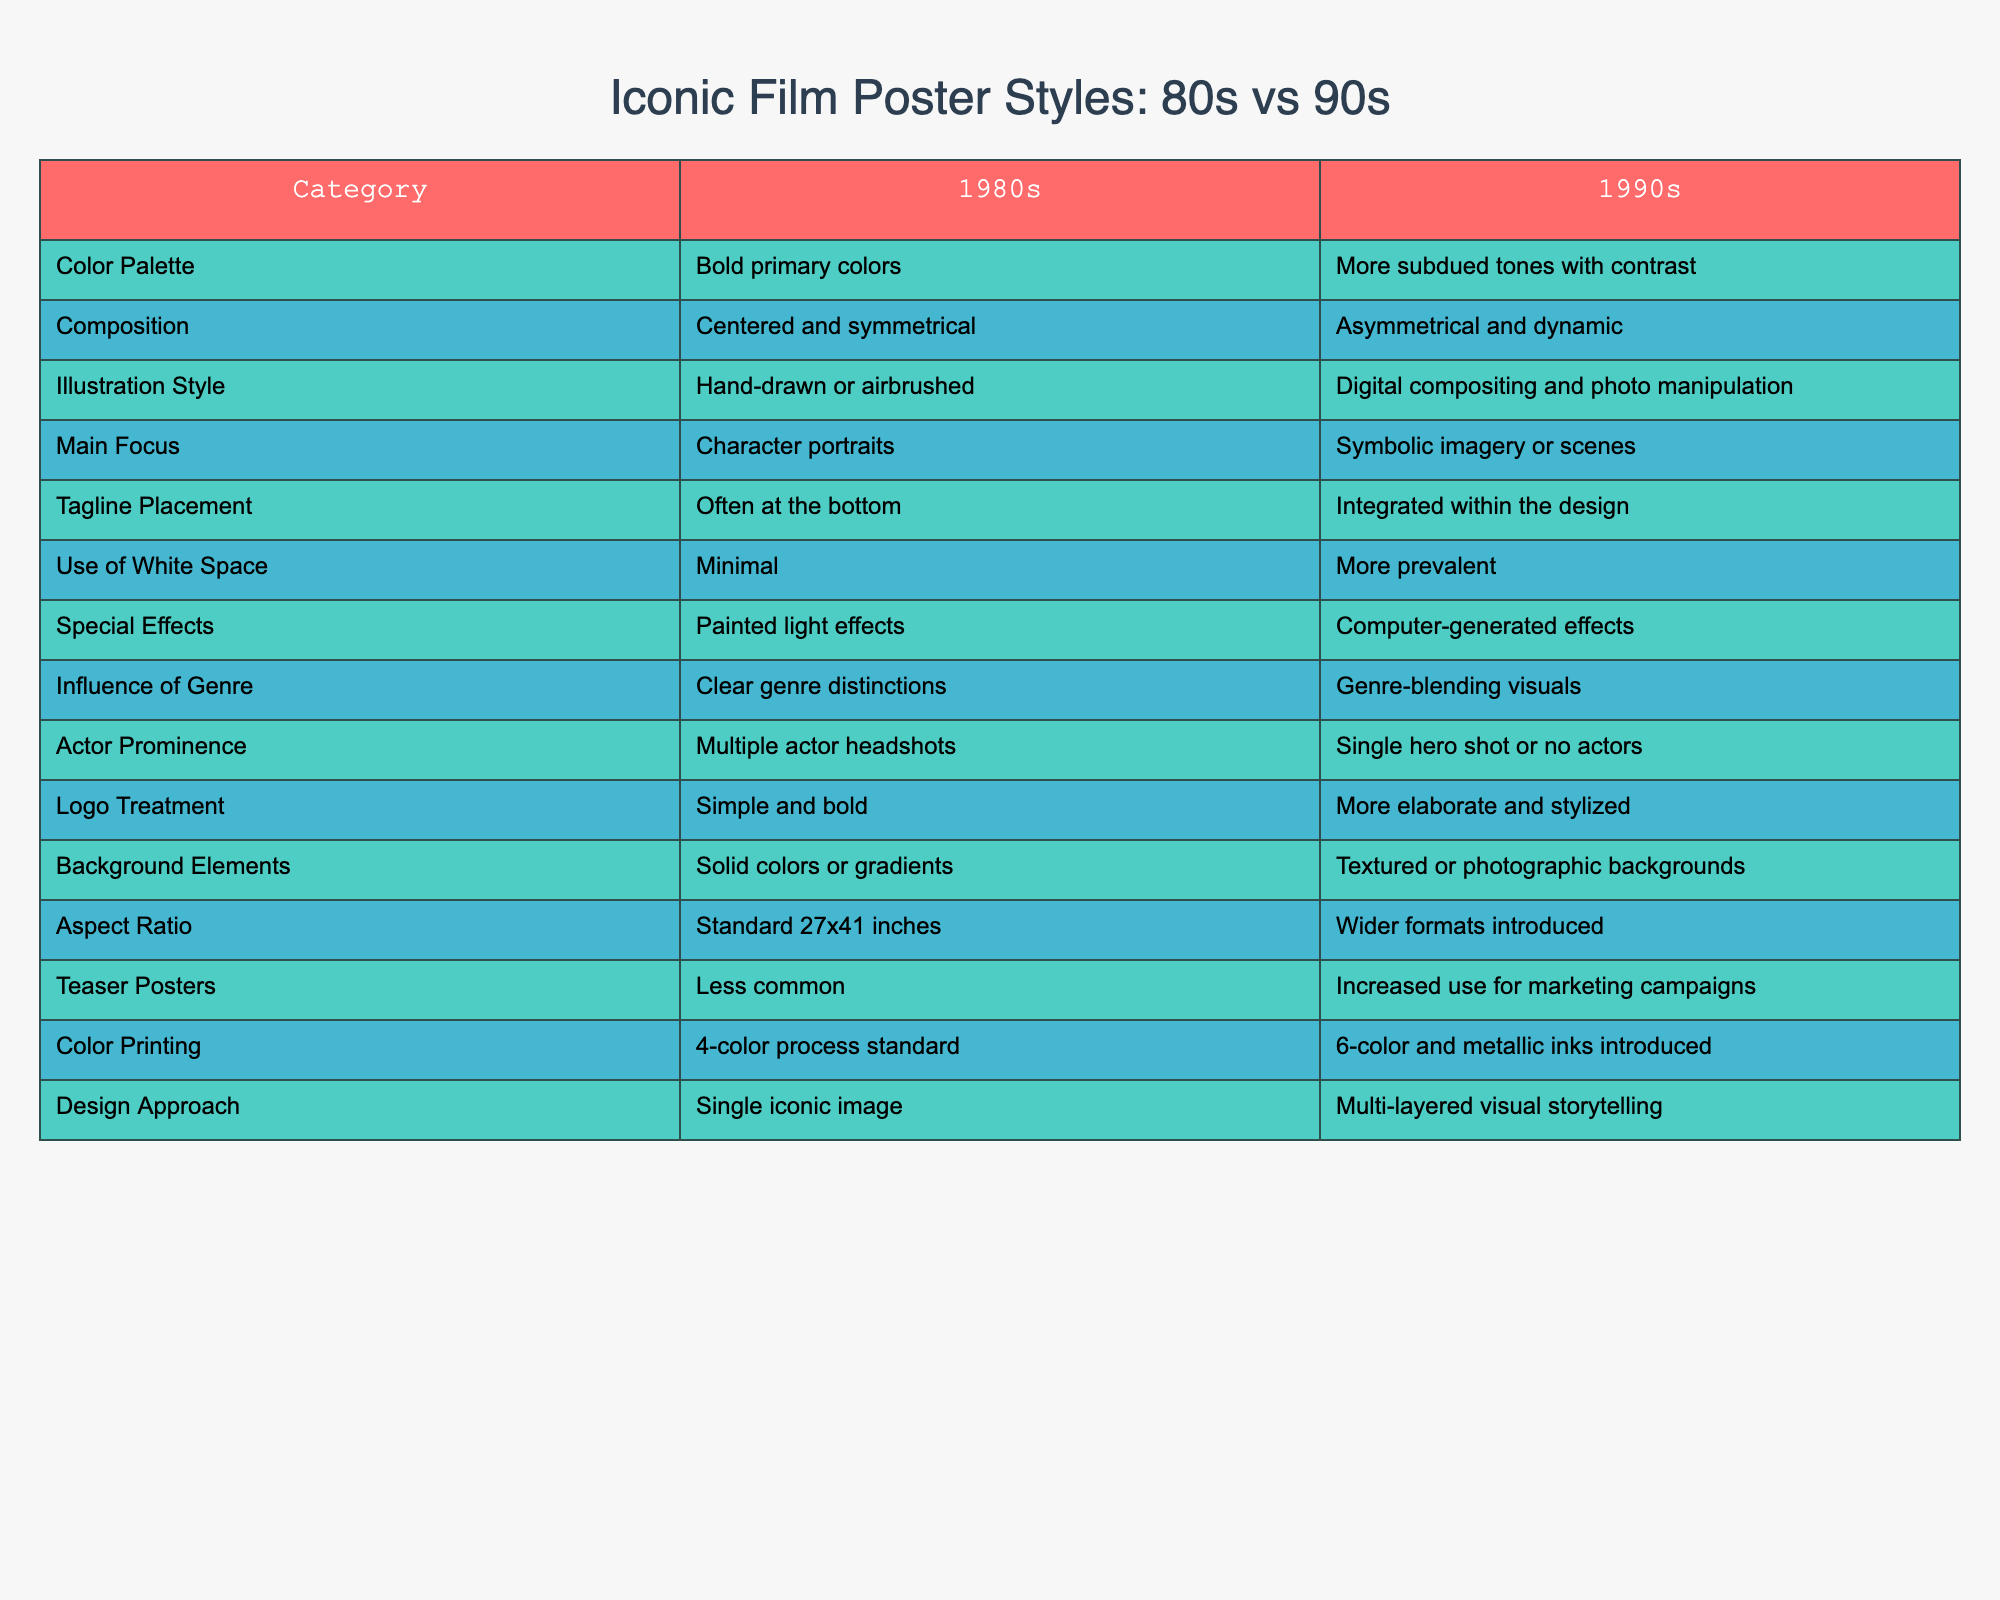What is the primary color palette of film posters in the 1980s? Referring to the table, the color palette for the 1980s is described as "Bold primary colors."
Answer: Bold primary colors How are the main focuses of film poster design different between the 1980s and 1990s? In the 1980s, the main focus is "Character portraits," while in the 1990s, it shifts to "Symbolic imagery or scenes." This shows a shift from straightforward character representation to more abstract or conceptual visuals.
Answer: Character portraits vs. Symbolic imagery or scenes Is the use of special effects in film posters greater in the 1990s than in the 1980s? The table indicates that the special effects in the 1980s are "Painted light effects," while in the 1990s, they include "Computer-generated effects," suggesting that the 1990s had more advanced special effects.
Answer: Yes Which decade saw an increase in the use of teaser posters? The table highlights that teaser posters were "Less common" in the 1980s and that there was "Increased use for marketing campaigns" in the 1990s, indicating a shift in marketing strategies.
Answer: 1990s What is the difference in composition style between the two decades? The table states that 1980s compositions are "Centered and symmetrical," while 1990s compositions are "Asymmetrical and dynamic," illustrating a shift towards more energetic designs in the 1990s.
Answer: Centered and symmetrical vs. Asymmetrical and dynamic How many color printing processes were standard in the 1980s compared to the 1990s? In the 1980s, the standard was a "4-color process," while in the 1990s it increased to "6-color and metallic inks." This shows an enhancement in printing technology and options over the decade.
Answer: 4-color vs. 6-color Does the logo treatment become simpler or more elaborate in the 1990s compared to the 1980s? The table mentions that the logo treatment in the 1980s is "Simple and bold," while in the 1990s it becomes "More elaborate and stylized," indicating complexity increased in the later decade.
Answer: More elaborate How does the use of white space compare between the two decades? The table shows that in the 1980s, the use of white space is described as "Minimal," whereas in the 1990s, it is "More prevalent," suggesting a different approach to layout and design.
Answer: Minimal vs. More prevalent 